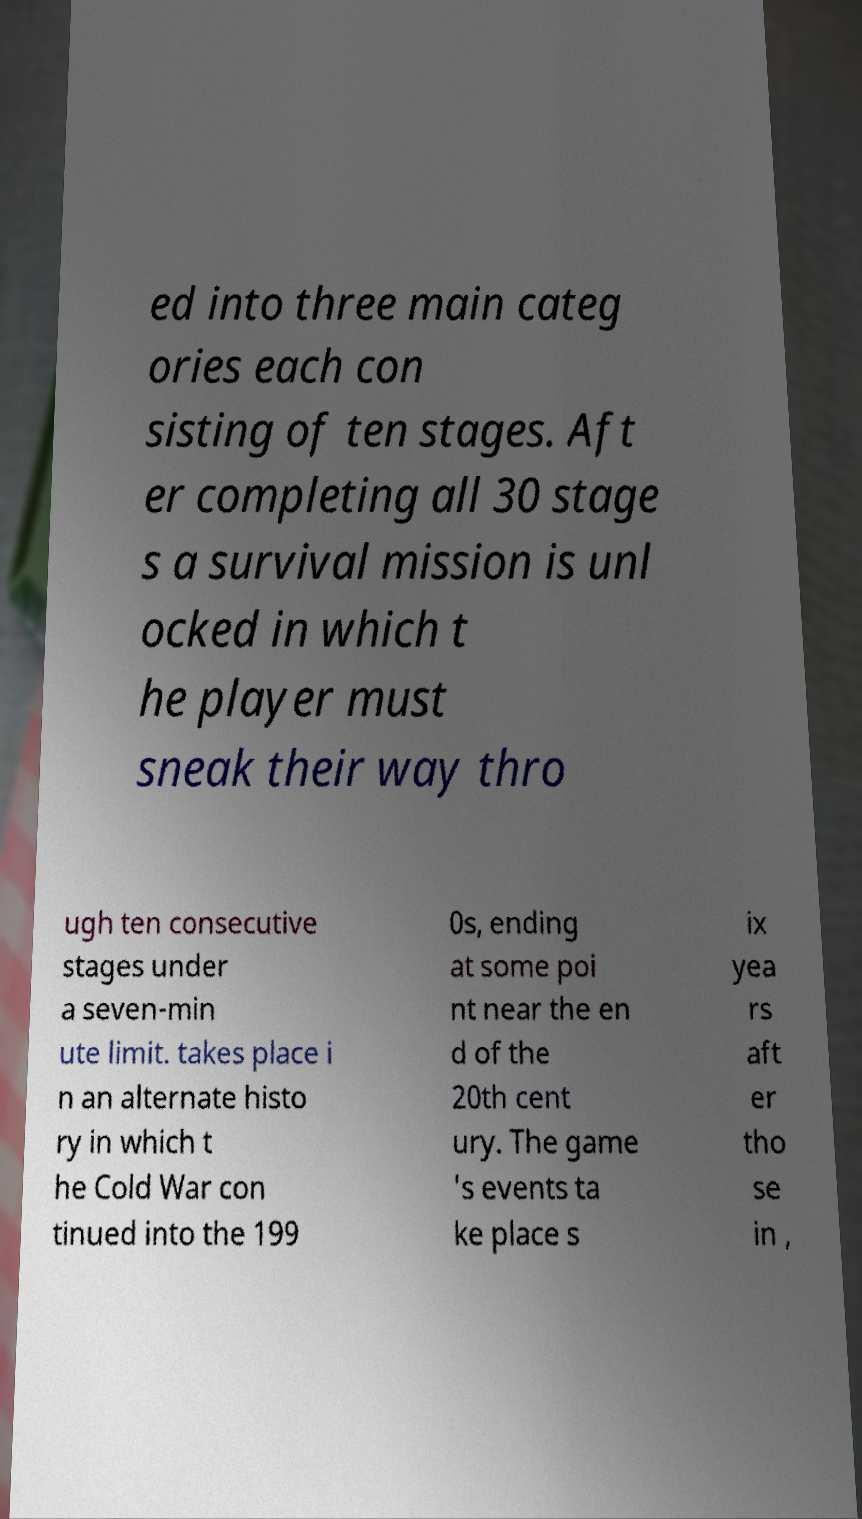There's text embedded in this image that I need extracted. Can you transcribe it verbatim? ed into three main categ ories each con sisting of ten stages. Aft er completing all 30 stage s a survival mission is unl ocked in which t he player must sneak their way thro ugh ten consecutive stages under a seven-min ute limit. takes place i n an alternate histo ry in which t he Cold War con tinued into the 199 0s, ending at some poi nt near the en d of the 20th cent ury. The game 's events ta ke place s ix yea rs aft er tho se in , 